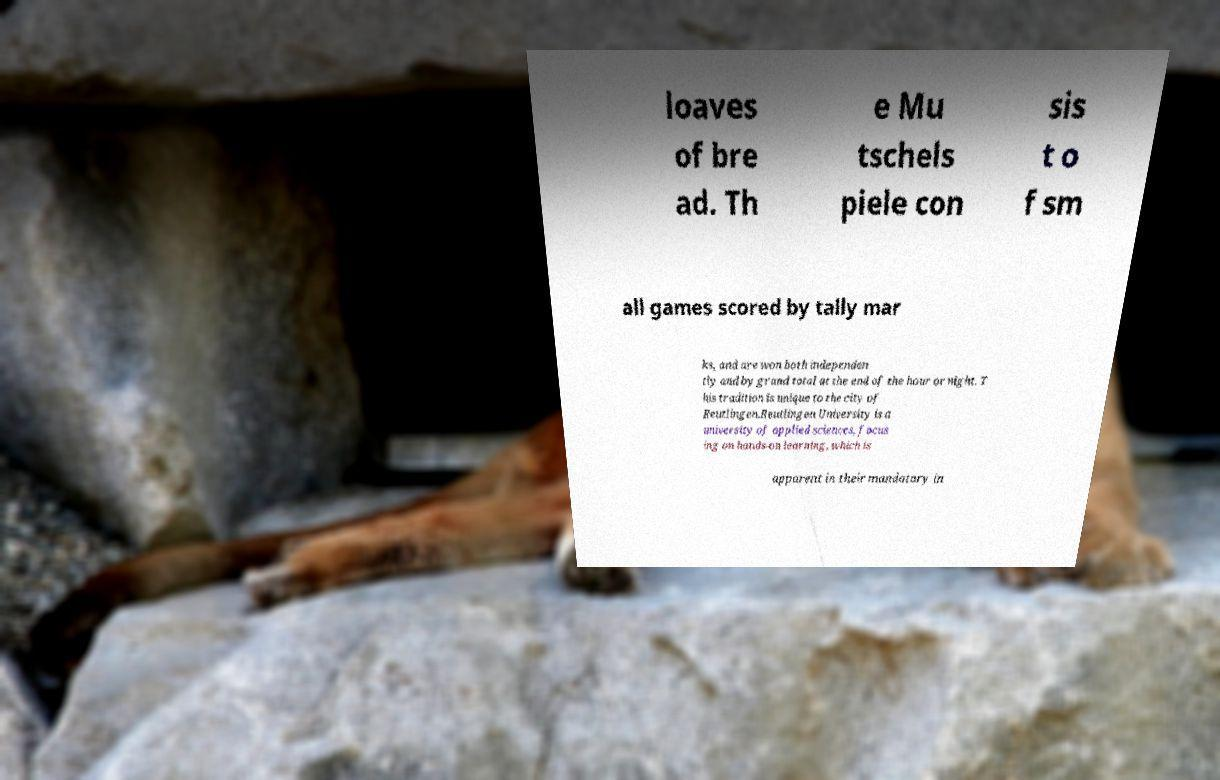Could you extract and type out the text from this image? loaves of bre ad. Th e Mu tschels piele con sis t o f sm all games scored by tally mar ks, and are won both independen tly and by grand total at the end of the hour or night. T his tradition is unique to the city of Reutlingen.Reutlingen University is a university of applied sciences, focus ing on hands-on learning, which is apparent in their mandatory in 